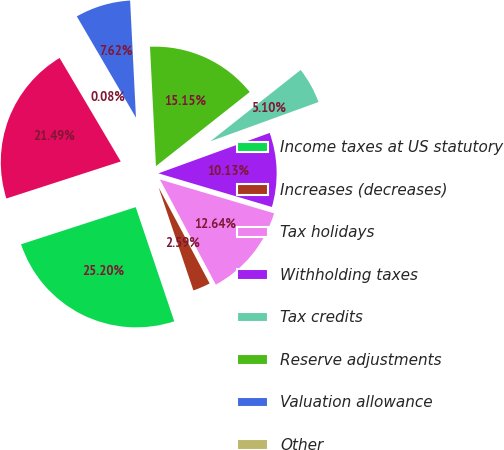Convert chart. <chart><loc_0><loc_0><loc_500><loc_500><pie_chart><fcel>Income taxes at US statutory<fcel>Increases (decreases)<fcel>Tax holidays<fcel>Withholding taxes<fcel>Tax credits<fcel>Reserve adjustments<fcel>Valuation allowance<fcel>Other<fcel>Provision for income taxes as<nl><fcel>25.2%<fcel>2.59%<fcel>12.64%<fcel>10.13%<fcel>5.1%<fcel>15.15%<fcel>7.62%<fcel>0.08%<fcel>21.49%<nl></chart> 